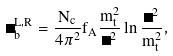Convert formula to latex. <formula><loc_0><loc_0><loc_500><loc_500>\Delta _ { b } ^ { L , R } = \frac { N _ { c } } { 4 \pi ^ { 2 } } f _ { A } \frac { m _ { t } ^ { 2 } } { \Lambda ^ { 2 } } \ln \frac { \Lambda ^ { 2 } } { m _ { t } ^ { 2 } } ,</formula> 